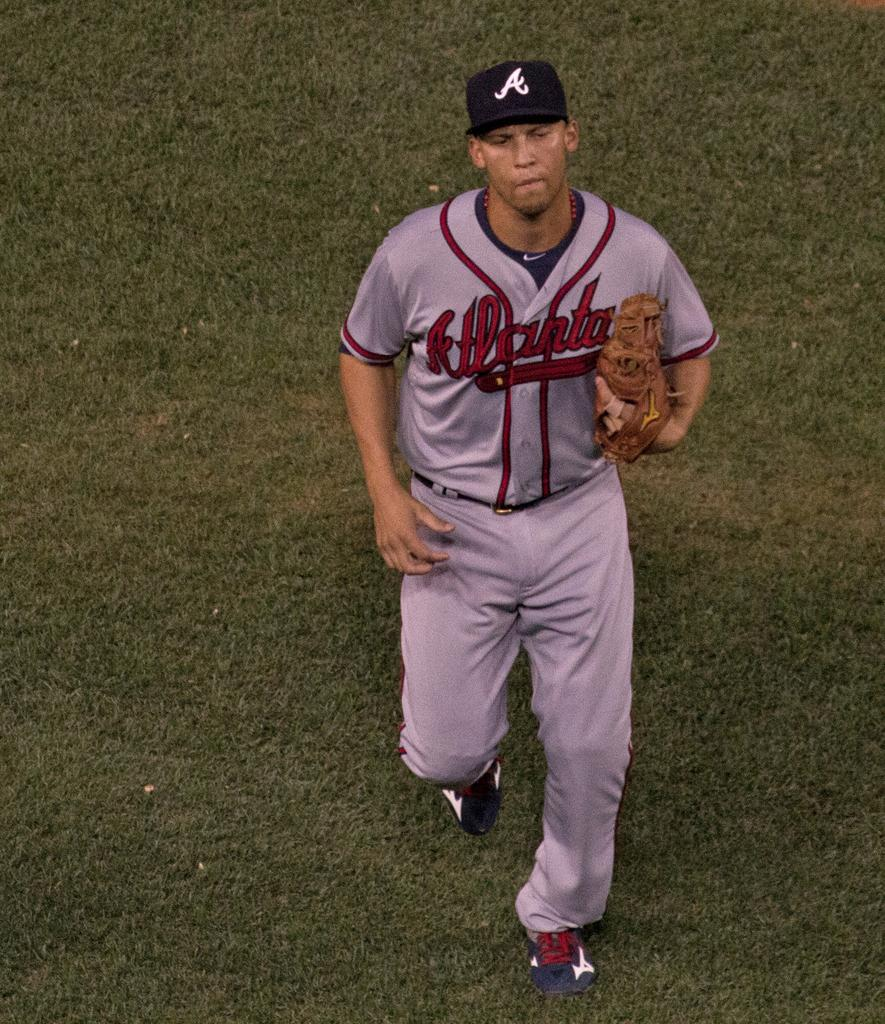<image>
Relay a brief, clear account of the picture shown. A man is wearing an Atlanta baseball uniform. 